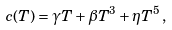<formula> <loc_0><loc_0><loc_500><loc_500>c ( T ) = \gamma T + \beta T ^ { 3 } + \eta T ^ { 5 } \, ,</formula> 